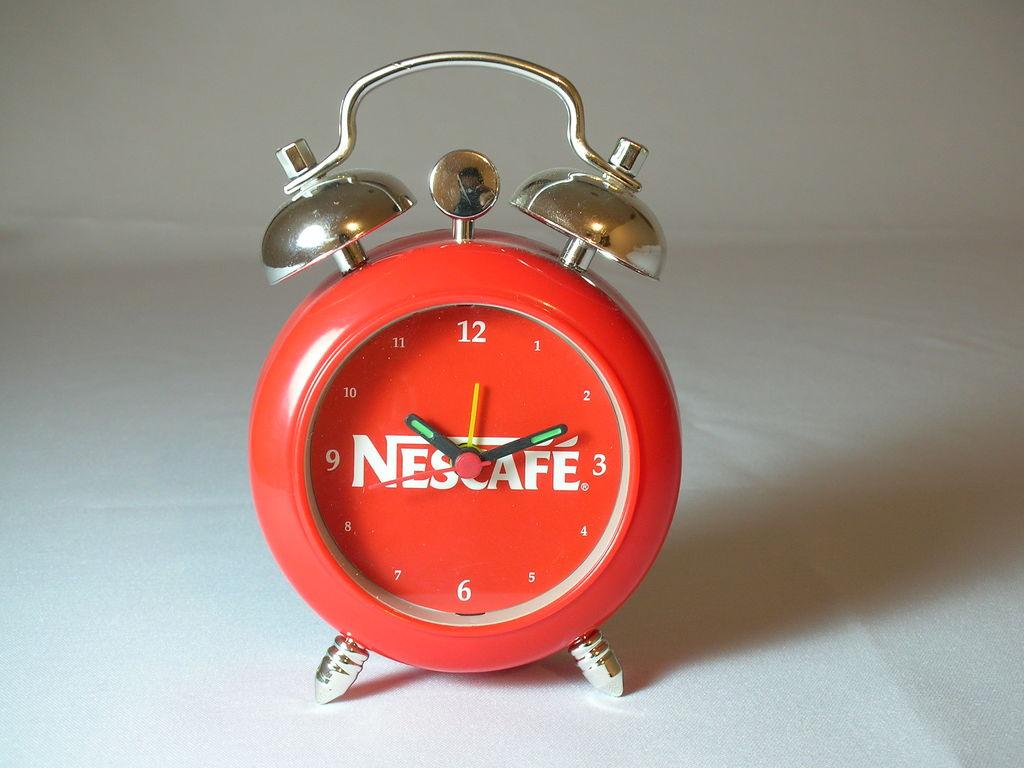What number is the yellow hand pointing near?
Offer a terse response. 12. What brand is in the center?
Your answer should be compact. Nescafe. 